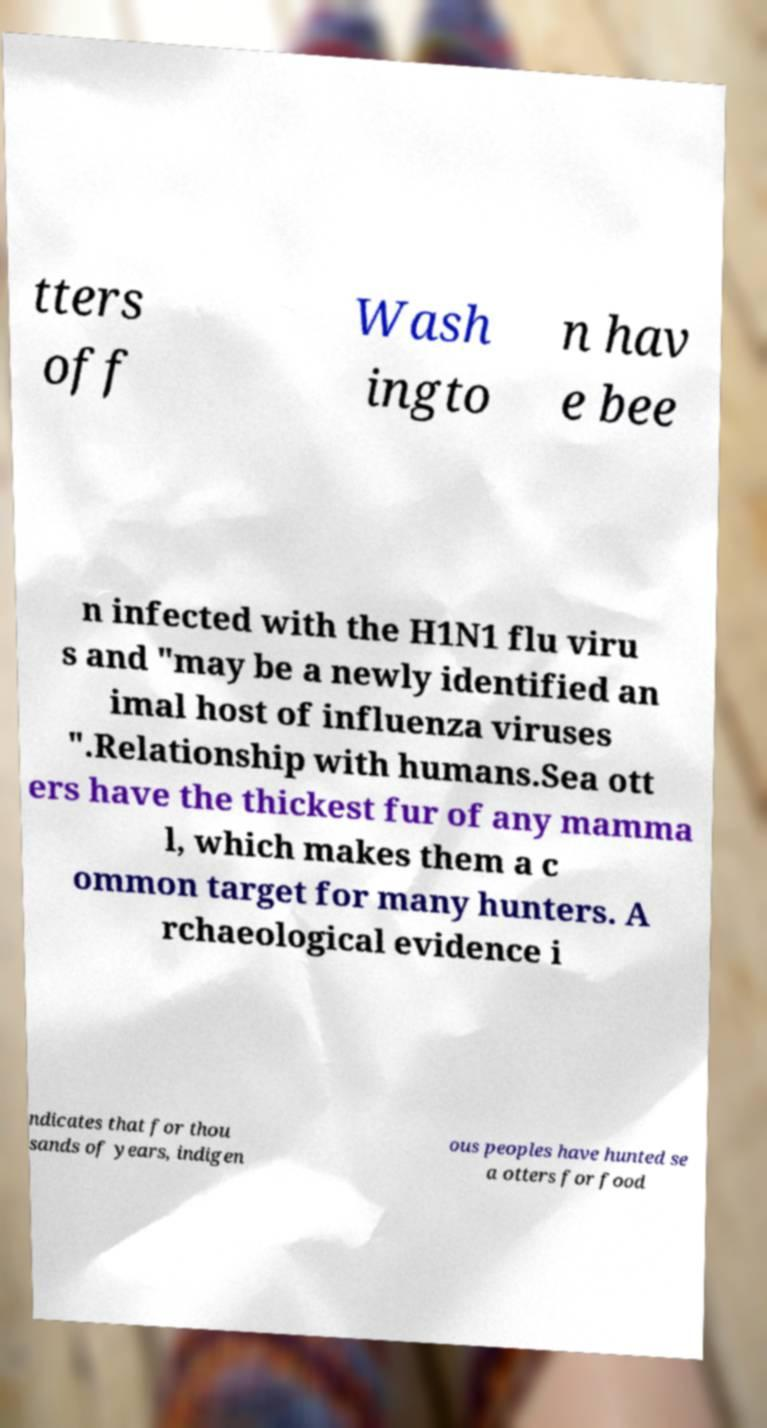Could you extract and type out the text from this image? tters off Wash ingto n hav e bee n infected with the H1N1 flu viru s and "may be a newly identified an imal host of influenza viruses ".Relationship with humans.Sea ott ers have the thickest fur of any mamma l, which makes them a c ommon target for many hunters. A rchaeological evidence i ndicates that for thou sands of years, indigen ous peoples have hunted se a otters for food 